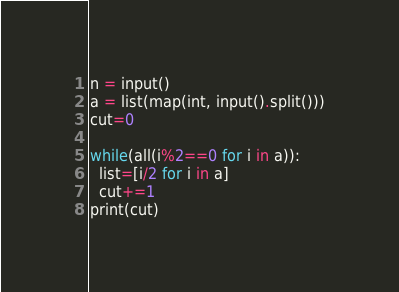<code> <loc_0><loc_0><loc_500><loc_500><_Python_>n = input()
a = list(map(int, input().split()))
cut=0

while(all(i%2==0 for i in a)):
  list=[i/2 for i in a]
  cut+=1
print(cut)</code> 